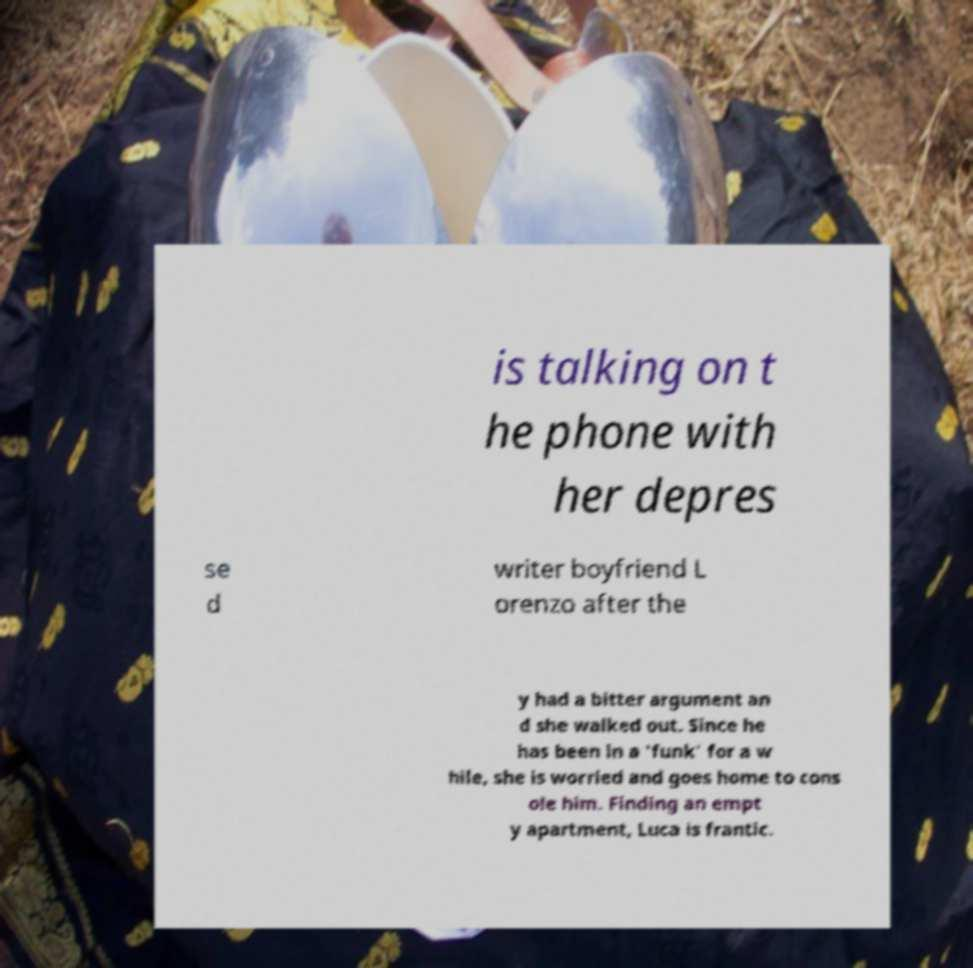Can you read and provide the text displayed in the image?This photo seems to have some interesting text. Can you extract and type it out for me? is talking on t he phone with her depres se d writer boyfriend L orenzo after the y had a bitter argument an d she walked out. Since he has been in a 'funk' for a w hile, she is worried and goes home to cons ole him. Finding an empt y apartment, Luca is frantic. 